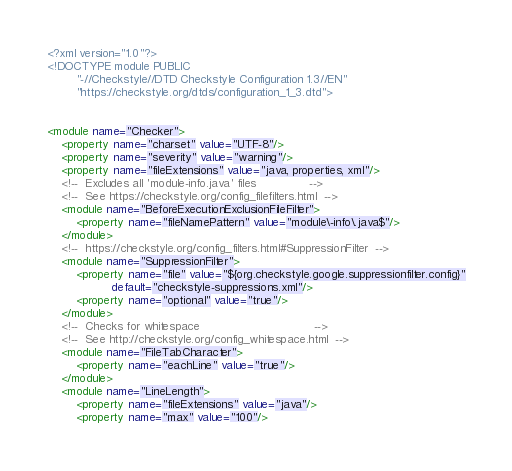Convert code to text. <code><loc_0><loc_0><loc_500><loc_500><_XML_><?xml version="1.0"?>
<!DOCTYPE module PUBLIC
        "-//Checkstyle//DTD Checkstyle Configuration 1.3//EN"
        "https://checkstyle.org/dtds/configuration_1_3.dtd">


<module name="Checker">
    <property name="charset" value="UTF-8"/>
    <property name="severity" value="warning"/>
    <property name="fileExtensions" value="java, properties, xml"/>
    <!--  Excludes all 'module-info.java' files               -->
    <!--  See https://checkstyle.org/config_filefilters.html  -->
    <module name="BeforeExecutionExclusionFileFilter">
        <property name="fileNamePattern" value="module\-info\.java$"/>
    </module>
    <!--  https://checkstyle.org/config_filters.html#SuppressionFilter  -->
    <module name="SuppressionFilter">
        <property name="file" value="${org.checkstyle.google.suppressionfilter.config}"
                  default="checkstyle-suppressions.xml"/>
        <property name="optional" value="true"/>
    </module>
    <!--  Checks for whitespace                                -->
    <!--  See http://checkstyle.org/config_whitespace.html  -->
    <module name="FileTabCharacter">
        <property name="eachLine" value="true"/>
    </module>
    <module name="LineLength">
        <property name="fileExtensions" value="java"/>
        <property name="max" value="100"/></code> 